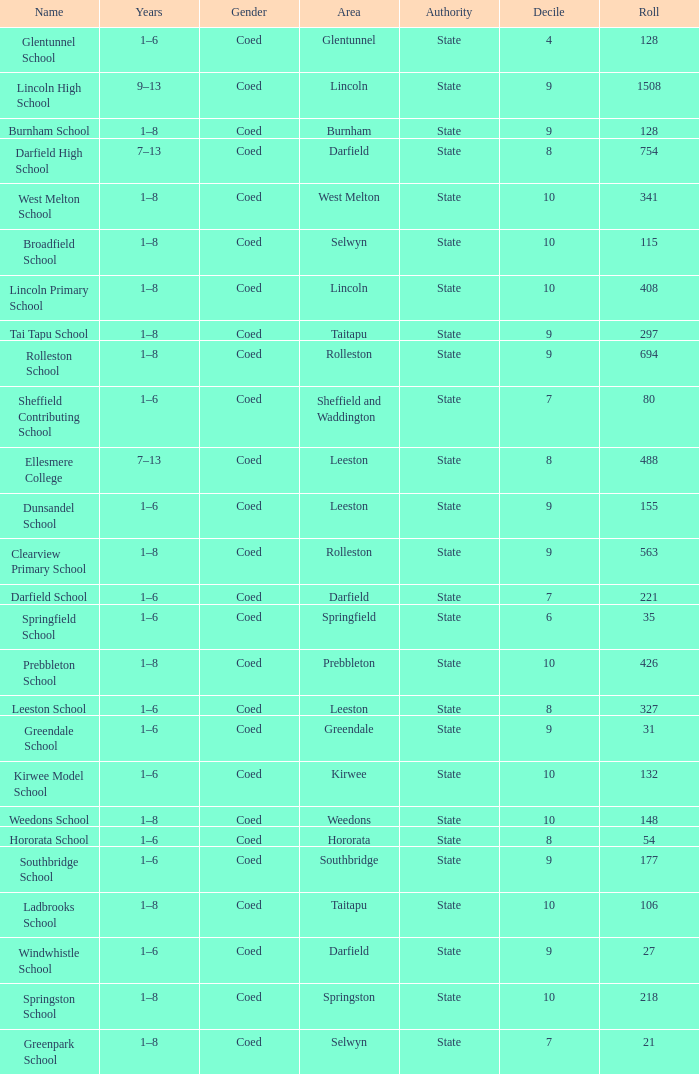What is the name with a Decile less than 10, and a Roll of 297? Tai Tapu School. 